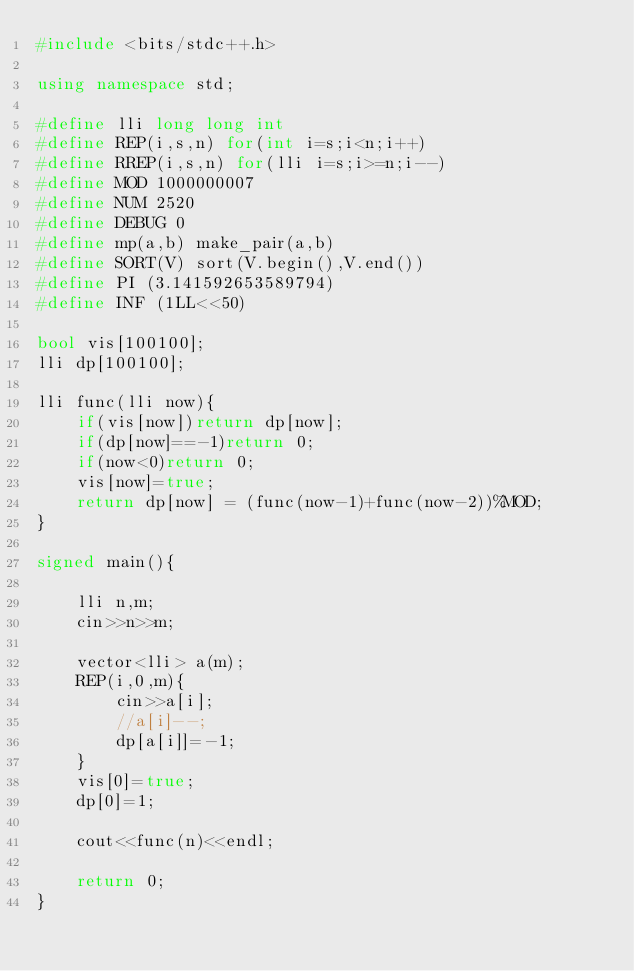Convert code to text. <code><loc_0><loc_0><loc_500><loc_500><_C++_>#include <bits/stdc++.h>

using namespace std;

#define lli long long int
#define REP(i,s,n) for(int i=s;i<n;i++)
#define RREP(i,s,n) for(lli i=s;i>=n;i--)
#define MOD 1000000007
#define NUM 2520
#define DEBUG 0
#define mp(a,b) make_pair(a,b)
#define SORT(V) sort(V.begin(),V.end())
#define PI (3.141592653589794)
#define INF (1LL<<50)

bool vis[100100];
lli dp[100100];

lli func(lli now){
	if(vis[now])return dp[now];
	if(dp[now]==-1)return 0;
	if(now<0)return 0;
	vis[now]=true;
	return dp[now] = (func(now-1)+func(now-2))%MOD;
}

signed main(){

	lli n,m;
	cin>>n>>m;

	vector<lli> a(m);
	REP(i,0,m){
		cin>>a[i];
		//a[i]--;
		dp[a[i]]=-1;
	}
	vis[0]=true;
	dp[0]=1;

	cout<<func(n)<<endl;

	return 0;
}</code> 